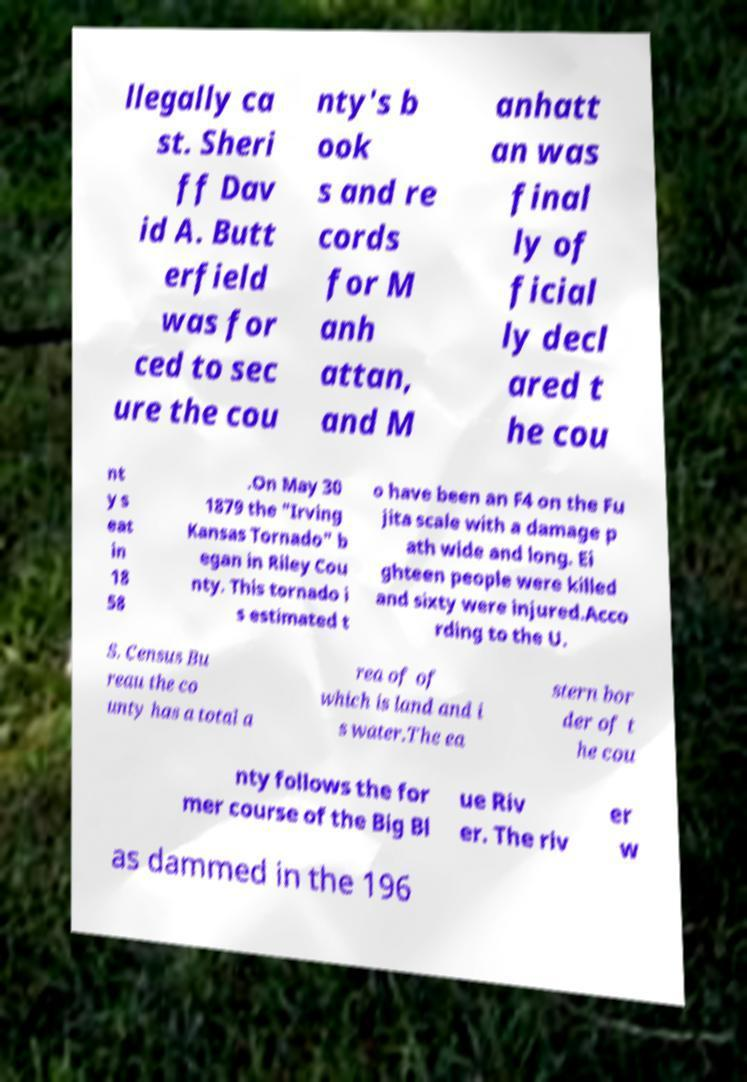Please read and relay the text visible in this image. What does it say? llegally ca st. Sheri ff Dav id A. Butt erfield was for ced to sec ure the cou nty's b ook s and re cords for M anh attan, and M anhatt an was final ly of ficial ly decl ared t he cou nt y s eat in 18 58 .On May 30 1879 the "Irving Kansas Tornado" b egan in Riley Cou nty. This tornado i s estimated t o have been an F4 on the Fu jita scale with a damage p ath wide and long. Ei ghteen people were killed and sixty were injured.Acco rding to the U. S. Census Bu reau the co unty has a total a rea of of which is land and i s water.The ea stern bor der of t he cou nty follows the for mer course of the Big Bl ue Riv er. The riv er w as dammed in the 196 